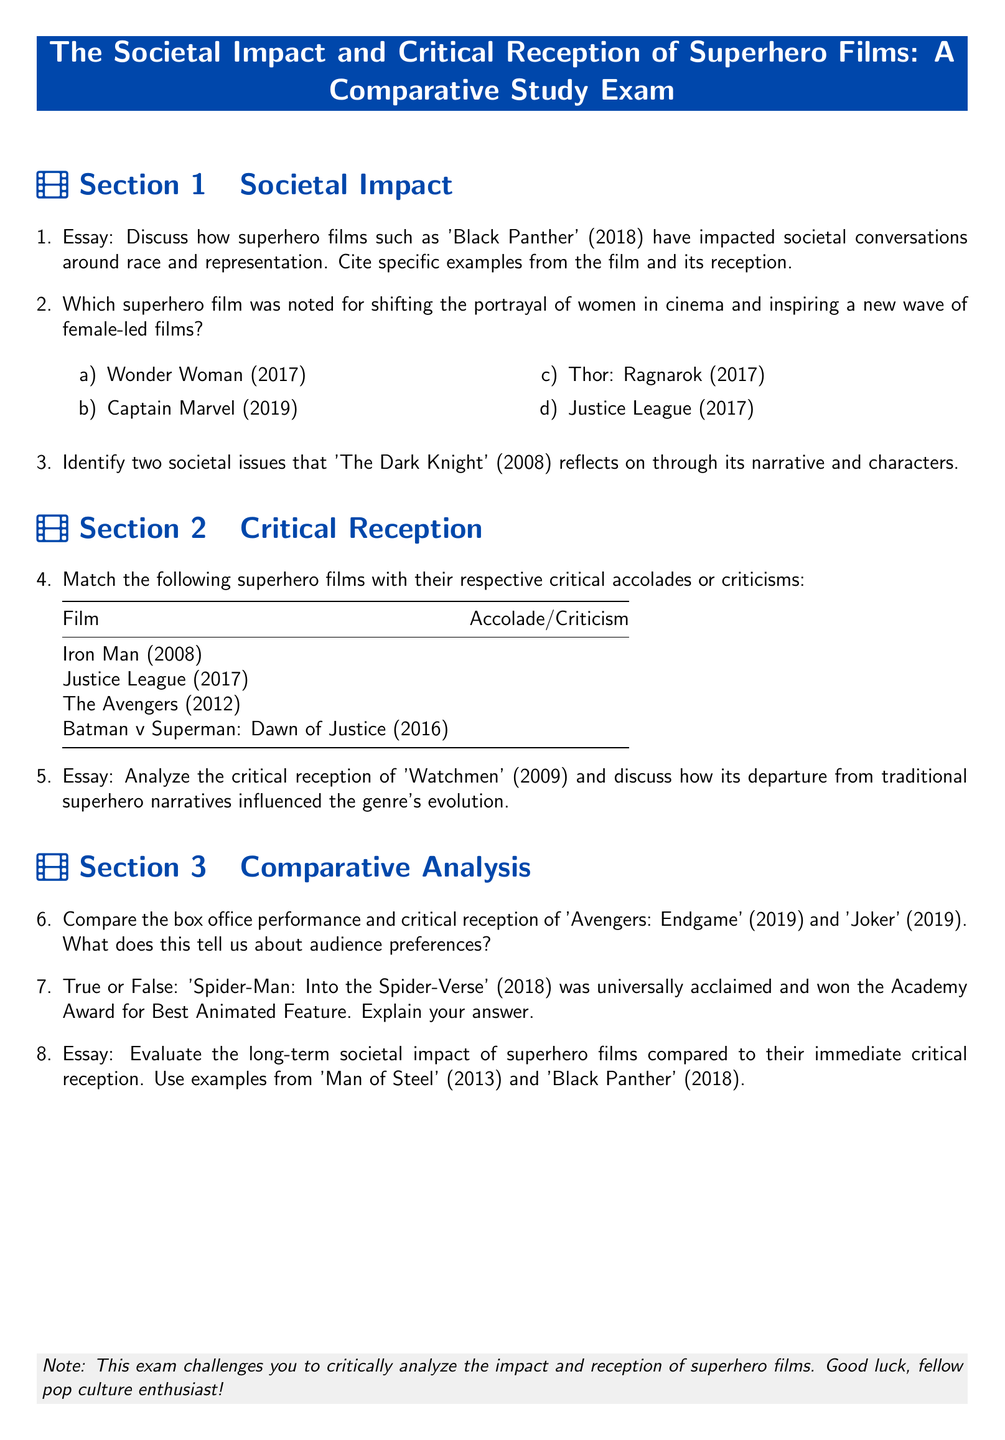What is the title of the exam? The title of the exam is clearly stated at the top of the document in a prominent box.
Answer: The Societal Impact and Critical Reception of Superhero Films: A Comparative Study Exam Which film is noted for its impact on societal conversations around race and representation? The document mentions a specific film that is highlighted for this societal impact in Section 1.
Answer: Black Panther What year was 'Wonder Woman' released? The document lists 'Wonder Woman' in a multiple-choice question, providing the release year.
Answer: 2017 What are the two societal issues reflected in 'The Dark Knight'? The essay question asks for identification but does not provide the issues, requiring reasoning based on knowledge of the film.
Answer: [Answer requires reasoning; not directly stated] How many superhero films are matched with their accolades or criticisms? The document contains a matching section with four films listed for matching.
Answer: 4 What notable Academy Award did 'Spider-Man: Into the Spider-Verse' win? The true or false question in the document hints at the significance of this film winning a specific award.
Answer: Best Animated Feature Which film’s critical reception is analyzed for its departure from traditional narratives? The essay question specifies a film recognized for its non-traditional narrative style.
Answer: Watchmen What two superhero films are compared for box office performance in Section 3? The comparison asks about two films, which are explicitly listed in the document.
Answer: Avengers: Endgame and Joker How is the document structured? The structure comprises multiple sections that categorize the questions about societal impact, critical reception, and comparative analysis.
Answer: Sections 